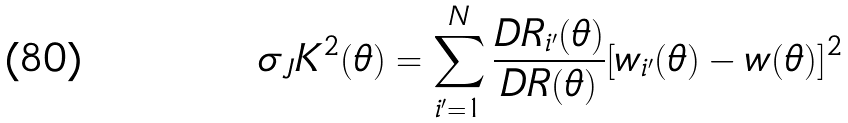<formula> <loc_0><loc_0><loc_500><loc_500>\sigma _ { J } K ^ { 2 } ( \theta ) = \sum _ { i ^ { \prime } = 1 } ^ { N } \frac { D R _ { i ^ { \prime } } ( \theta ) } { D R ( \theta ) } [ w _ { i ^ { \prime } } ( \theta ) - w ( \theta ) ] ^ { 2 }</formula> 